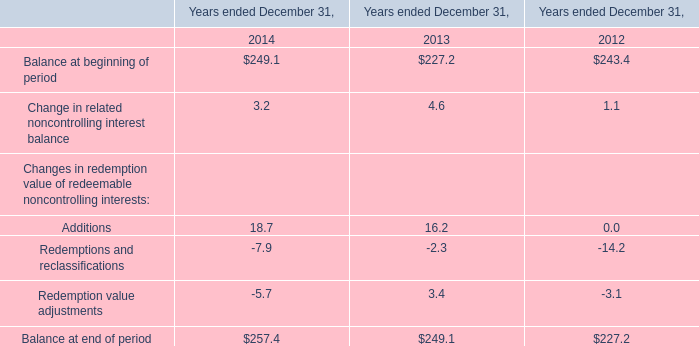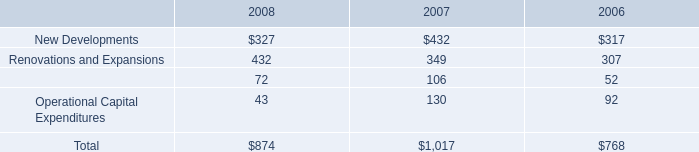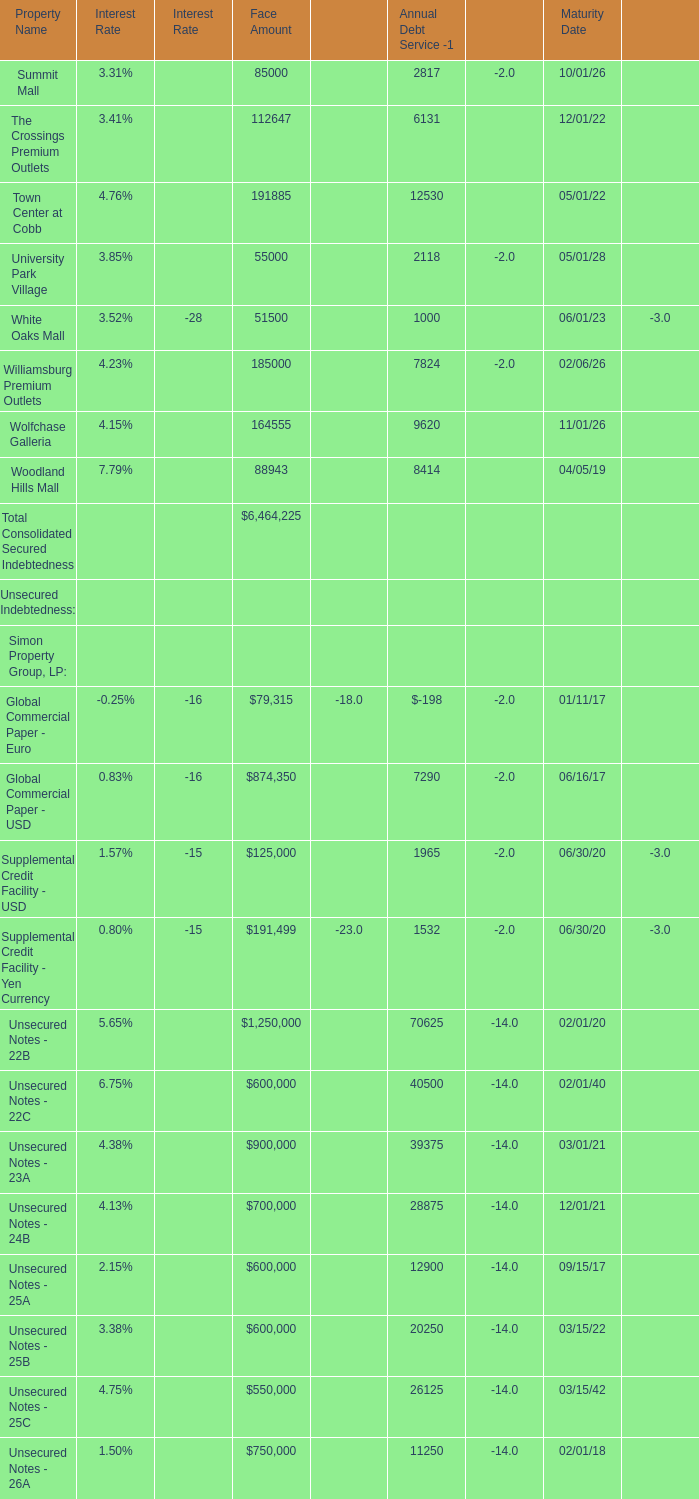What's the 50 % of the Total Consolidated Indebtedness at Face Amounts? 
Computations: (0.5 * 23099450)
Answer: 11549725.0. 